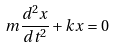Convert formula to latex. <formula><loc_0><loc_0><loc_500><loc_500>m \frac { d ^ { 2 } x } { d t ^ { 2 } } + k x = 0</formula> 